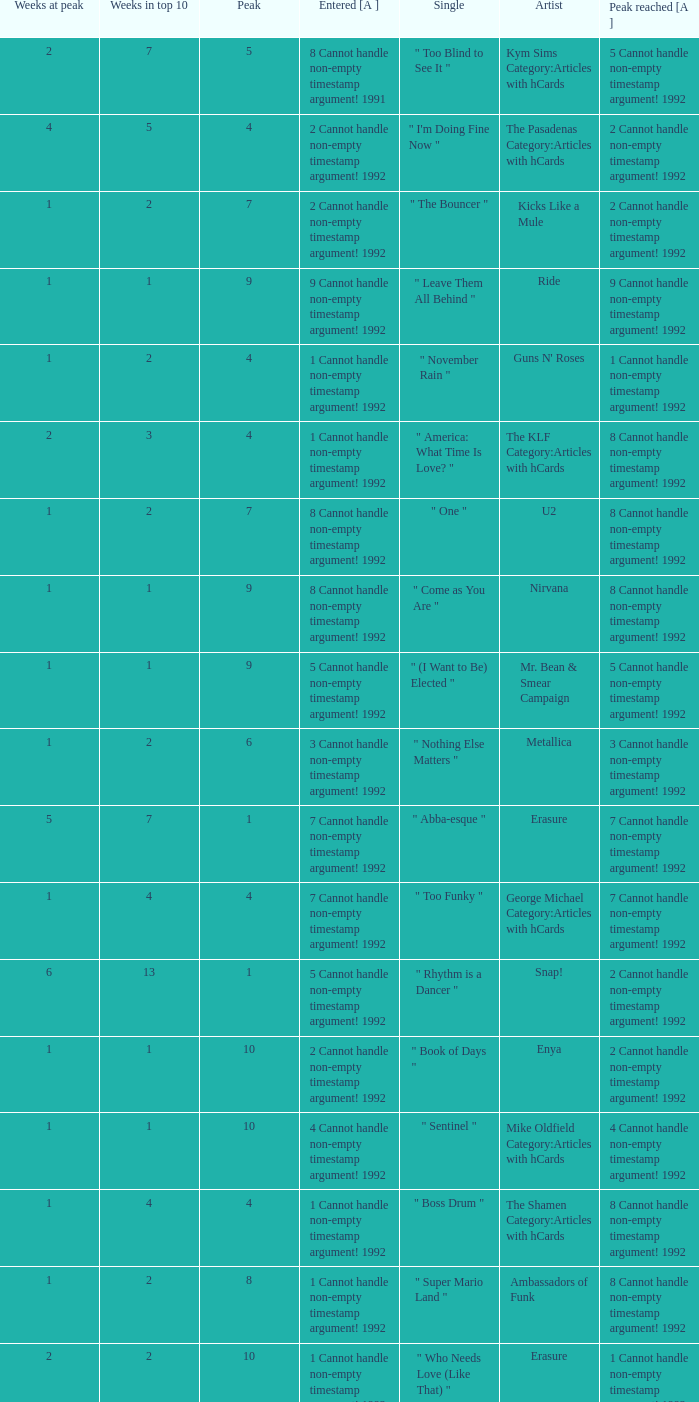What was the peak reached for a single with 4 weeks in the top 10 and entered in 7 cannot handle non-empty timestamp argument! 1992? 7 Cannot handle non-empty timestamp argument! 1992. 